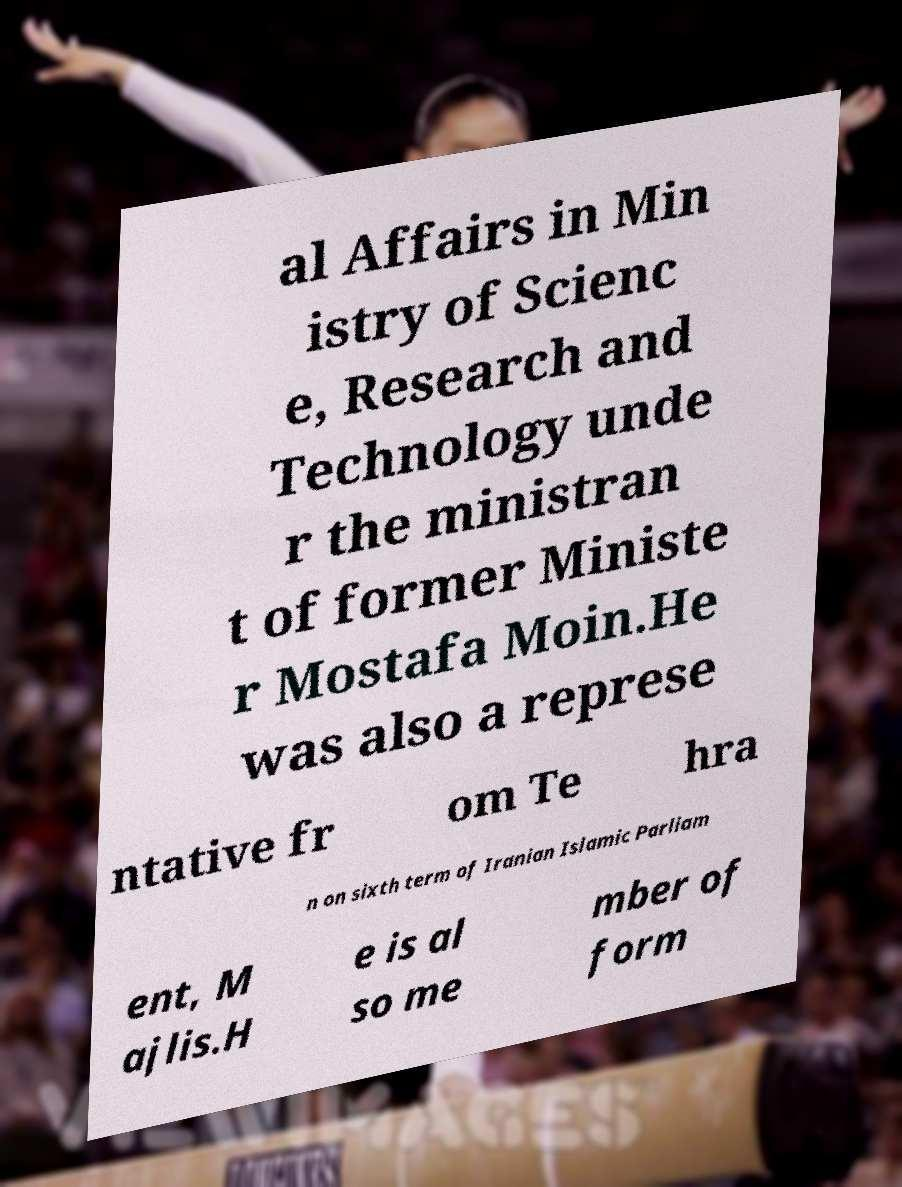Could you extract and type out the text from this image? al Affairs in Min istry of Scienc e, Research and Technology unde r the ministran t of former Ministe r Mostafa Moin.He was also a represe ntative fr om Te hra n on sixth term of Iranian Islamic Parliam ent, M ajlis.H e is al so me mber of form 